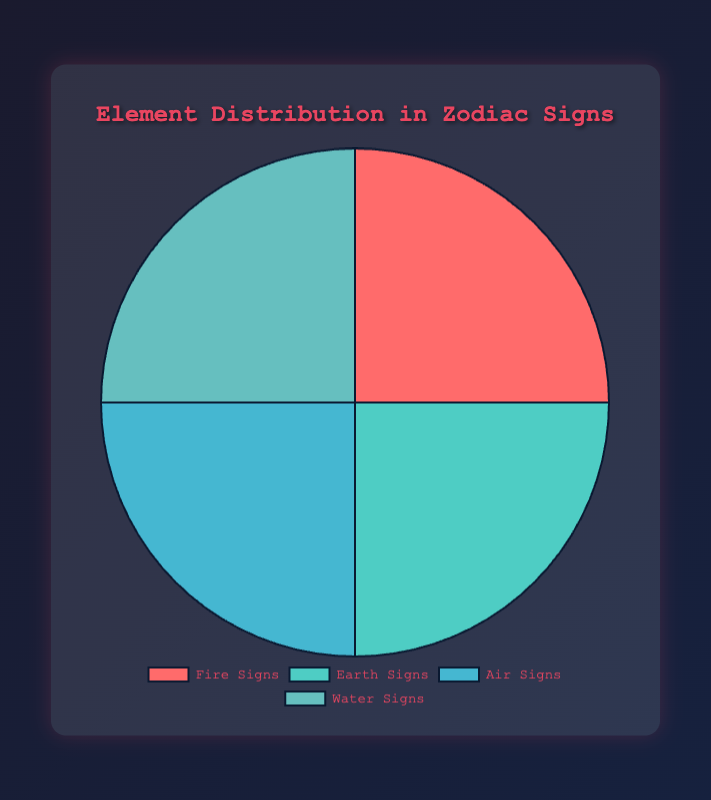What's the total percentage of Earth and Water signs combined? Add the percentages of Earth signs (25%) and Water signs (25%): 25 + 25 = 50.
Answer: 50 Which element has the same percentage as Air signs? The chart shows that Fire signs, Earth signs, and Water signs all have the same percentage (25%) as Air signs.
Answer: Fire signs, Earth signs, Water signs Are Fire signs greater than, less than, or equal to Water signs in percentage? The chart shows both Fire signs and Water signs have a percentage of 25. Therefore, they are equal.
Answer: Equal What is the most prevalent element in Zodiac signs based on the pie chart? All elements (Fire, Earth, Air, Water) are represented equally with 25%. Thus, there is no single most prevalent element.
Answer: None How many elements share the highest percentage in the chart? Since all four elements (Fire, Earth, Air, Water) share the same highest percentage of 25%, the number of elements is 4.
Answer: 4 If the percentage of Fire signs were increased by 15%, what would the new percentage be? Adding 15% to the current 25% for Fire signs: 25 + 15 = 40.
Answer: 40 Given that all elements occupy equal portions, what visual feature in the chart confirms this? In the pie chart, each section (representing Fire, Earth, Air, Water) is visually the same size, indicating equal distribution percentages.
Answer: Same size sections What would be the new average percentage per element if Earth signs were reduced to 15%? With Earth signs at 15%: Fire 25% + Air 25% + Water 25% + Earth 15% = 90%. The average is 90% / 4 = 22.5%.
Answer: 22.5 By what percentage does each element contribute to the total percentage in the chart? Since each element (Fire, Earth, Air, Water) represents 25% of the total and the total is 100%, each element contributes 25/100 * 100 = 25%.
Answer: 25 If the distribution were to be made unequal, with Fire signs doubled to 50%, how would the new percentages distribute assuming the total remains constant? With Fire signs taking 50%, the remaining 50% is split among Earth, Air, and Water. Let each of Earth, Air, and Water be x. The equation becomes 50 + 3x = 100, so x = (100 - 50) / 3 = 16.67%. New percentages are Fire: 50%, Earth, Air, and Water: 16.67% each.
Answer: Fire: 50%, Earth, Air, Water: 16.67% 